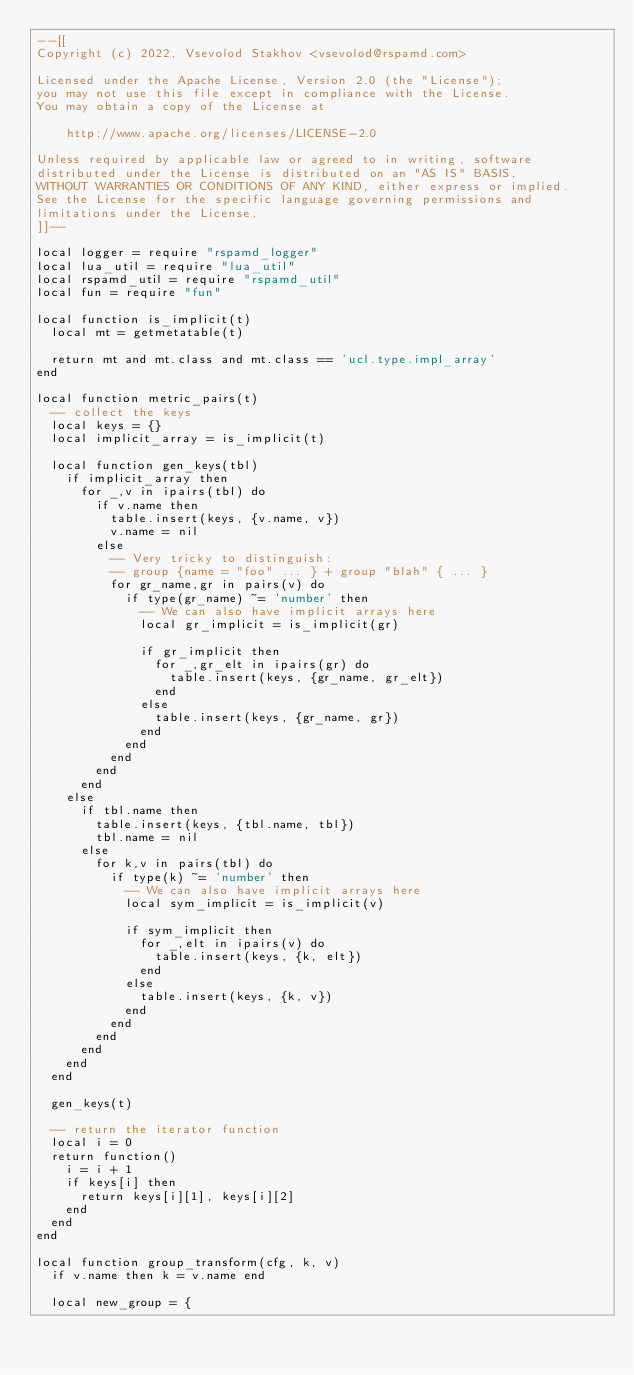<code> <loc_0><loc_0><loc_500><loc_500><_Lua_>--[[
Copyright (c) 2022, Vsevolod Stakhov <vsevolod@rspamd.com>

Licensed under the Apache License, Version 2.0 (the "License");
you may not use this file except in compliance with the License.
You may obtain a copy of the License at

    http://www.apache.org/licenses/LICENSE-2.0

Unless required by applicable law or agreed to in writing, software
distributed under the License is distributed on an "AS IS" BASIS,
WITHOUT WARRANTIES OR CONDITIONS OF ANY KIND, either express or implied.
See the License for the specific language governing permissions and
limitations under the License.
]]--

local logger = require "rspamd_logger"
local lua_util = require "lua_util"
local rspamd_util = require "rspamd_util"
local fun = require "fun"

local function is_implicit(t)
  local mt = getmetatable(t)

  return mt and mt.class and mt.class == 'ucl.type.impl_array'
end

local function metric_pairs(t)
  -- collect the keys
  local keys = {}
  local implicit_array = is_implicit(t)

  local function gen_keys(tbl)
    if implicit_array then
      for _,v in ipairs(tbl) do
        if v.name then
          table.insert(keys, {v.name, v})
          v.name = nil
        else
          -- Very tricky to distinguish:
          -- group {name = "foo" ... } + group "blah" { ... }
          for gr_name,gr in pairs(v) do
            if type(gr_name) ~= 'number' then
              -- We can also have implicit arrays here
              local gr_implicit = is_implicit(gr)

              if gr_implicit then
                for _,gr_elt in ipairs(gr) do
                  table.insert(keys, {gr_name, gr_elt})
                end
              else
                table.insert(keys, {gr_name, gr})
              end
            end
          end
        end
      end
    else
      if tbl.name then
        table.insert(keys, {tbl.name, tbl})
        tbl.name = nil
      else
        for k,v in pairs(tbl) do
          if type(k) ~= 'number' then
            -- We can also have implicit arrays here
            local sym_implicit = is_implicit(v)

            if sym_implicit then
              for _,elt in ipairs(v) do
                table.insert(keys, {k, elt})
              end
            else
              table.insert(keys, {k, v})
            end
          end
        end
      end
    end
  end

  gen_keys(t)

  -- return the iterator function
  local i = 0
  return function()
    i = i + 1
    if keys[i] then
      return keys[i][1], keys[i][2]
    end
  end
end

local function group_transform(cfg, k, v)
  if v.name then k = v.name end

  local new_group = {</code> 